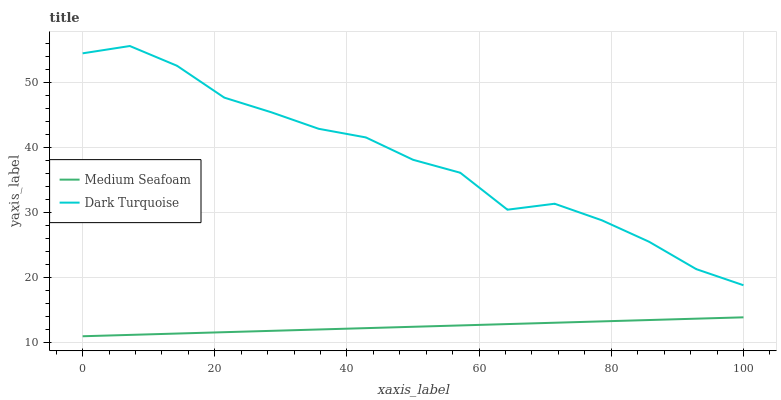Does Medium Seafoam have the minimum area under the curve?
Answer yes or no. Yes. Does Dark Turquoise have the maximum area under the curve?
Answer yes or no. Yes. Does Medium Seafoam have the maximum area under the curve?
Answer yes or no. No. Is Medium Seafoam the smoothest?
Answer yes or no. Yes. Is Dark Turquoise the roughest?
Answer yes or no. Yes. Is Medium Seafoam the roughest?
Answer yes or no. No. Does Medium Seafoam have the lowest value?
Answer yes or no. Yes. Does Dark Turquoise have the highest value?
Answer yes or no. Yes. Does Medium Seafoam have the highest value?
Answer yes or no. No. Is Medium Seafoam less than Dark Turquoise?
Answer yes or no. Yes. Is Dark Turquoise greater than Medium Seafoam?
Answer yes or no. Yes. Does Medium Seafoam intersect Dark Turquoise?
Answer yes or no. No. 